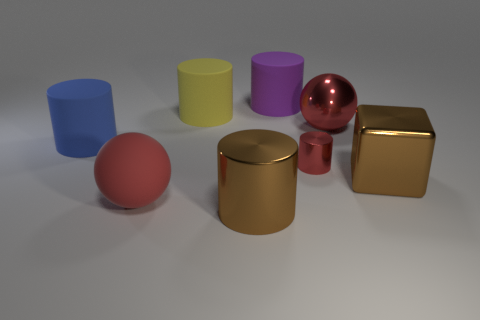There is a red sphere on the left side of the purple matte cylinder; is it the same size as the brown metal thing on the right side of the red metallic ball? The red sphere on the left appears to be similar in size to the brown cube on the right, giving the scene a balanced composition in terms of volume and space. 